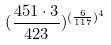Convert formula to latex. <formula><loc_0><loc_0><loc_500><loc_500>( \frac { 4 5 1 \cdot 3 } { 4 2 3 } ) ^ { ( \frac { 6 } { 1 1 7 } ) ^ { 4 } }</formula> 